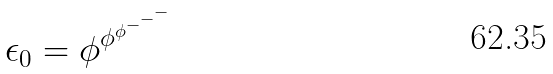Convert formula to latex. <formula><loc_0><loc_0><loc_500><loc_500>\epsilon _ { 0 } = \phi ^ { \phi ^ { \phi ^ { - ^ { - ^ { - } } } } }</formula> 